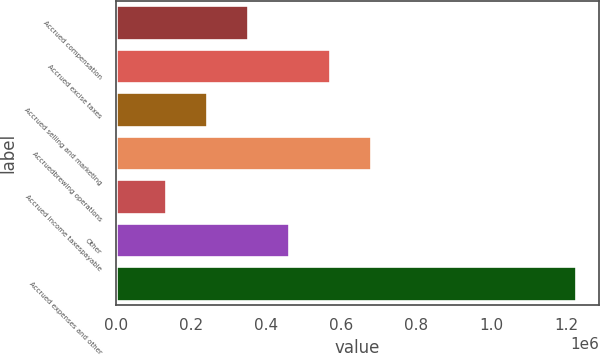Convert chart. <chart><loc_0><loc_0><loc_500><loc_500><bar_chart><fcel>Accrued compensation<fcel>Accrued excise taxes<fcel>Accrued selling and marketing<fcel>Accruedbrewing operations<fcel>Accrued income taxespayable<fcel>Other<fcel>Accrued expenses and other<nl><fcel>351305<fcel>569830<fcel>242043<fcel>679093<fcel>132780<fcel>460568<fcel>1.22541e+06<nl></chart> 